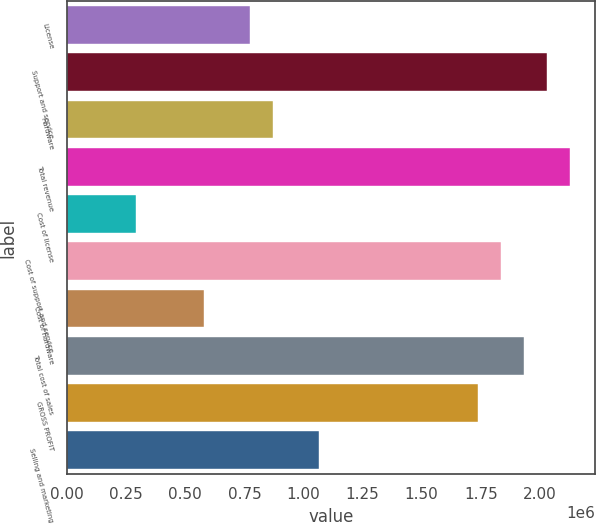<chart> <loc_0><loc_0><loc_500><loc_500><bar_chart><fcel>License<fcel>Support and service<fcel>Hardware<fcel>Total revenue<fcel>Cost of license<fcel>Cost of support and service<fcel>Cost of hardware<fcel>Total cost of sales<fcel>GROSS PROFIT<fcel>Selling and marketing<nl><fcel>773518<fcel>2.03048e+06<fcel>870207<fcel>2.12717e+06<fcel>290070<fcel>1.8371e+06<fcel>580139<fcel>1.93379e+06<fcel>1.74041e+06<fcel>1.06359e+06<nl></chart> 